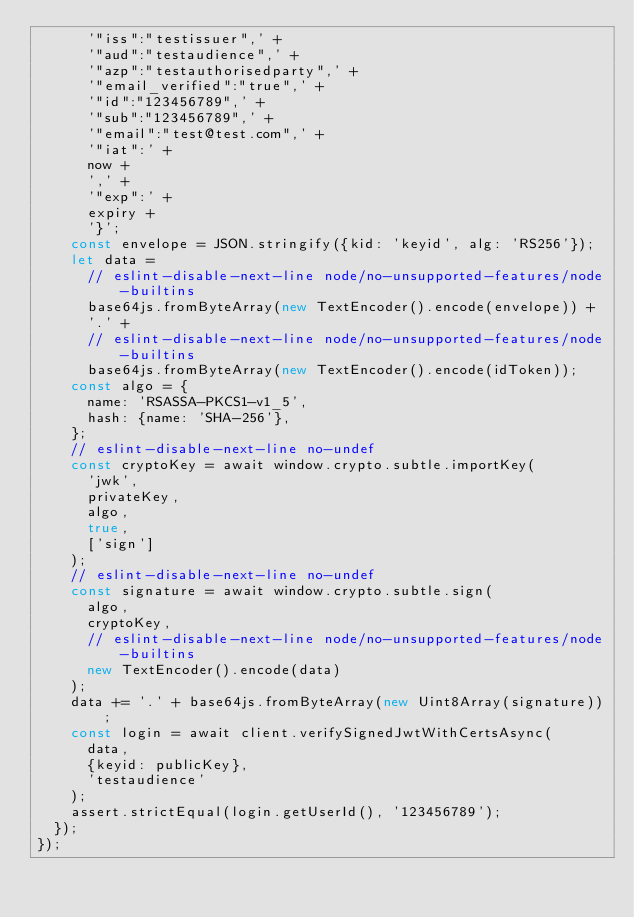<code> <loc_0><loc_0><loc_500><loc_500><_TypeScript_>      '"iss":"testissuer",' +
      '"aud":"testaudience",' +
      '"azp":"testauthorisedparty",' +
      '"email_verified":"true",' +
      '"id":"123456789",' +
      '"sub":"123456789",' +
      '"email":"test@test.com",' +
      '"iat":' +
      now +
      ',' +
      '"exp":' +
      expiry +
      '}';
    const envelope = JSON.stringify({kid: 'keyid', alg: 'RS256'});
    let data =
      // eslint-disable-next-line node/no-unsupported-features/node-builtins
      base64js.fromByteArray(new TextEncoder().encode(envelope)) +
      '.' +
      // eslint-disable-next-line node/no-unsupported-features/node-builtins
      base64js.fromByteArray(new TextEncoder().encode(idToken));
    const algo = {
      name: 'RSASSA-PKCS1-v1_5',
      hash: {name: 'SHA-256'},
    };
    // eslint-disable-next-line no-undef
    const cryptoKey = await window.crypto.subtle.importKey(
      'jwk',
      privateKey,
      algo,
      true,
      ['sign']
    );
    // eslint-disable-next-line no-undef
    const signature = await window.crypto.subtle.sign(
      algo,
      cryptoKey,
      // eslint-disable-next-line node/no-unsupported-features/node-builtins
      new TextEncoder().encode(data)
    );
    data += '.' + base64js.fromByteArray(new Uint8Array(signature));
    const login = await client.verifySignedJwtWithCertsAsync(
      data,
      {keyid: publicKey},
      'testaudience'
    );
    assert.strictEqual(login.getUserId(), '123456789');
  });
});
</code> 